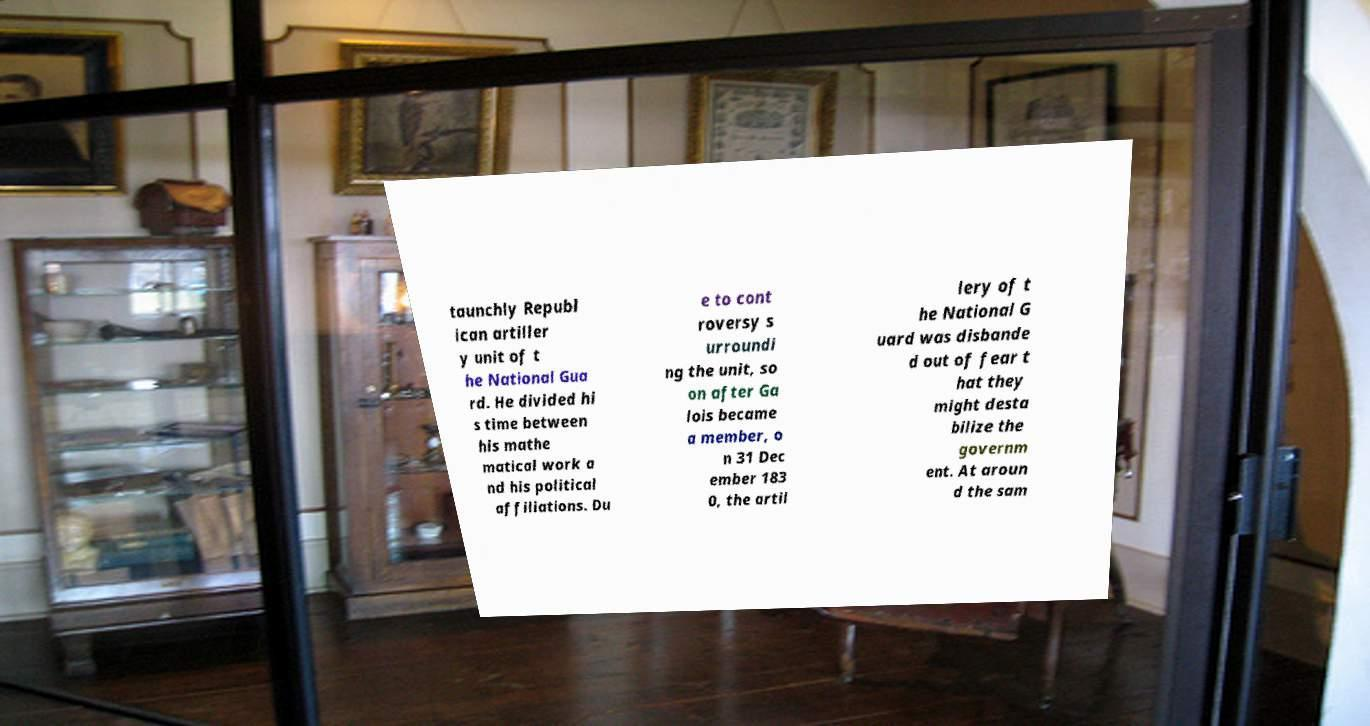I need the written content from this picture converted into text. Can you do that? taunchly Republ ican artiller y unit of t he National Gua rd. He divided hi s time between his mathe matical work a nd his political affiliations. Du e to cont roversy s urroundi ng the unit, so on after Ga lois became a member, o n 31 Dec ember 183 0, the artil lery of t he National G uard was disbande d out of fear t hat they might desta bilize the governm ent. At aroun d the sam 